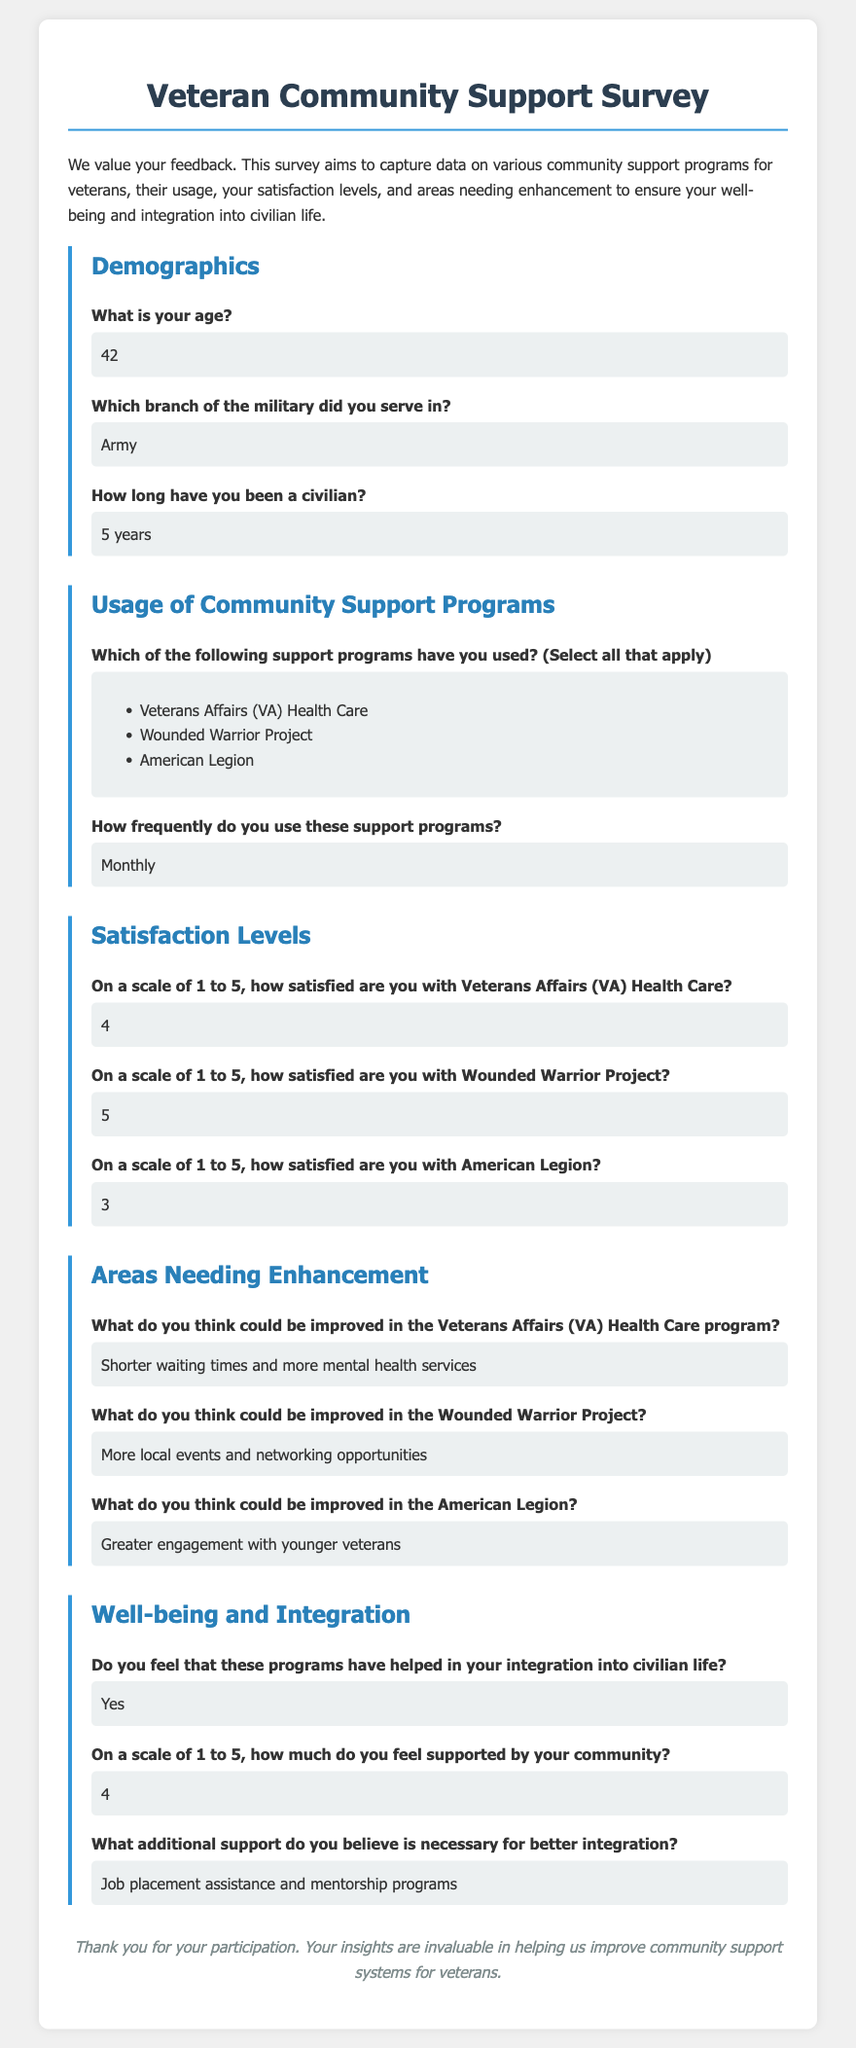What is the respondent's age? The age of the respondent is explicitly mentioned in the demographics section of the survey.
Answer: 42 Which military branch did the respondent serve in? The survey contains a specific answer about the respondent's military branch under the demographics section.
Answer: Army How long has the respondent been a civilian? The duration since the respondent transitioned to civilian life is stated in the demographics section of the survey.
Answer: 5 years What support program does the respondent use most frequently? The survey states the frequency of the respondent's use of support programs, which was mentioned in the corresponding section.
Answer: Monthly How satisfied is the respondent with the Wounded Warrior Project? The survey indicates the satisfaction level of the respondent regarding the Wounded Warrior Project on a scale of 1 to 5.
Answer: 5 What improvement does the respondent suggest for the Veteran Affairs Health Care program? The survey highlights specific suggestions from the respondent for enhancing the Veterans Affairs Health Care program in the areas needing enhancement section.
Answer: Shorter waiting times and more mental health services Does the respondent feel supported by the community? The survey explicitly asks whether the respondent feels supported by their community and includes their answer.
Answer: Yes On a scale of 1 to 5, how much support does the respondent feel from the community? The respondent’s rating on community support is stated clearly in the survey.
Answer: 4 What additional support does the respondent believe is necessary for better integration? The survey includes the respondent's thoughts on further requirements for better integration into civilian life.
Answer: Job placement assistance and mentorship programs 